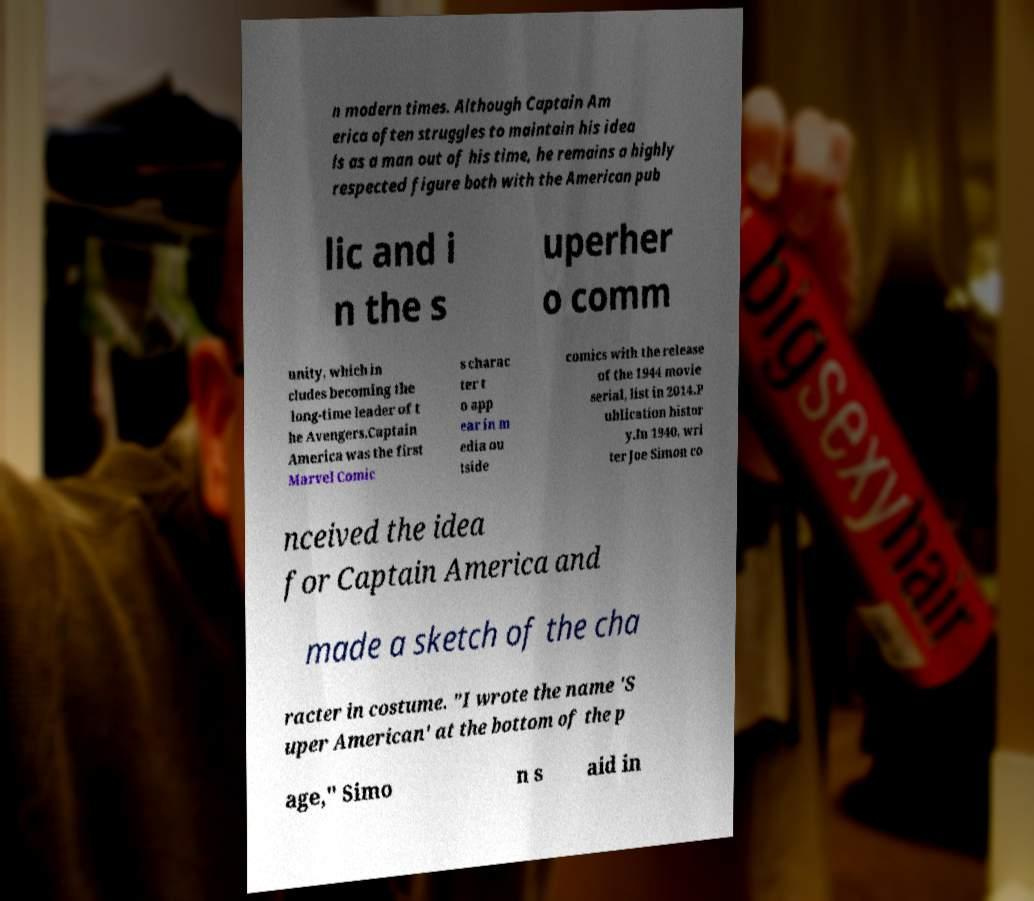Can you accurately transcribe the text from the provided image for me? n modern times. Although Captain Am erica often struggles to maintain his idea ls as a man out of his time, he remains a highly respected figure both with the American pub lic and i n the s uperher o comm unity, which in cludes becoming the long-time leader of t he Avengers.Captain America was the first Marvel Comic s charac ter t o app ear in m edia ou tside comics with the release of the 1944 movie serial, list in 2014.P ublication histor y.In 1940, wri ter Joe Simon co nceived the idea for Captain America and made a sketch of the cha racter in costume. "I wrote the name 'S uper American' at the bottom of the p age," Simo n s aid in 